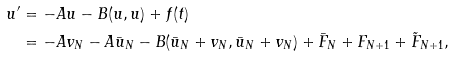<formula> <loc_0><loc_0><loc_500><loc_500>u ^ { \prime } & = - A u - B ( u , u ) + f ( t ) \\ & = - A v _ { N } - A \bar { u } _ { N } - B ( \bar { u } _ { N } + v _ { N } , \bar { u } _ { N } + v _ { N } ) + \bar { F } _ { N } + F _ { N + 1 } + \tilde { F } _ { N + 1 } ,</formula> 